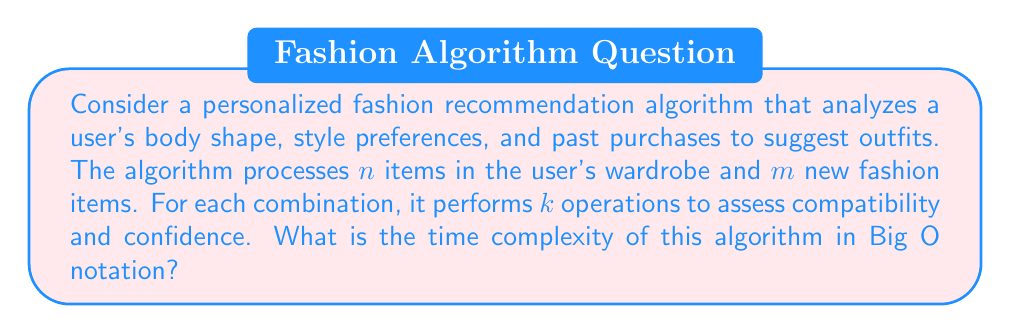What is the answer to this math problem? To analyze the time complexity of this algorithm, let's break it down step-by-step:

1. The algorithm needs to consider each item in the user's wardrobe ($n$) in combination with each new fashion item ($m$).

2. This creates $n * m$ combinations to analyze.

3. For each combination, the algorithm performs $k$ operations to assess compatibility and confidence.

4. Therefore, the total number of operations is $(n * m * k)$.

5. In Big O notation, we focus on the dominant terms and ignore constants. Here, $k$ can be considered a constant factor as it doesn't change with the input size.

6. Thus, we can simplify the complexity to $O(n * m)$.

This quadratic time complexity reflects the challenge of personalizing fashion recommendations, which might resonate with the persona's experience of finding outfits that boost confidence and body image. The algorithm's thoroughness in considering many combinations mirrors the care and attention one might put into choosing outfits that make them feel empowered, similar to how the persona looks up to their sister for inspiration.
Answer: $O(n * m)$ 